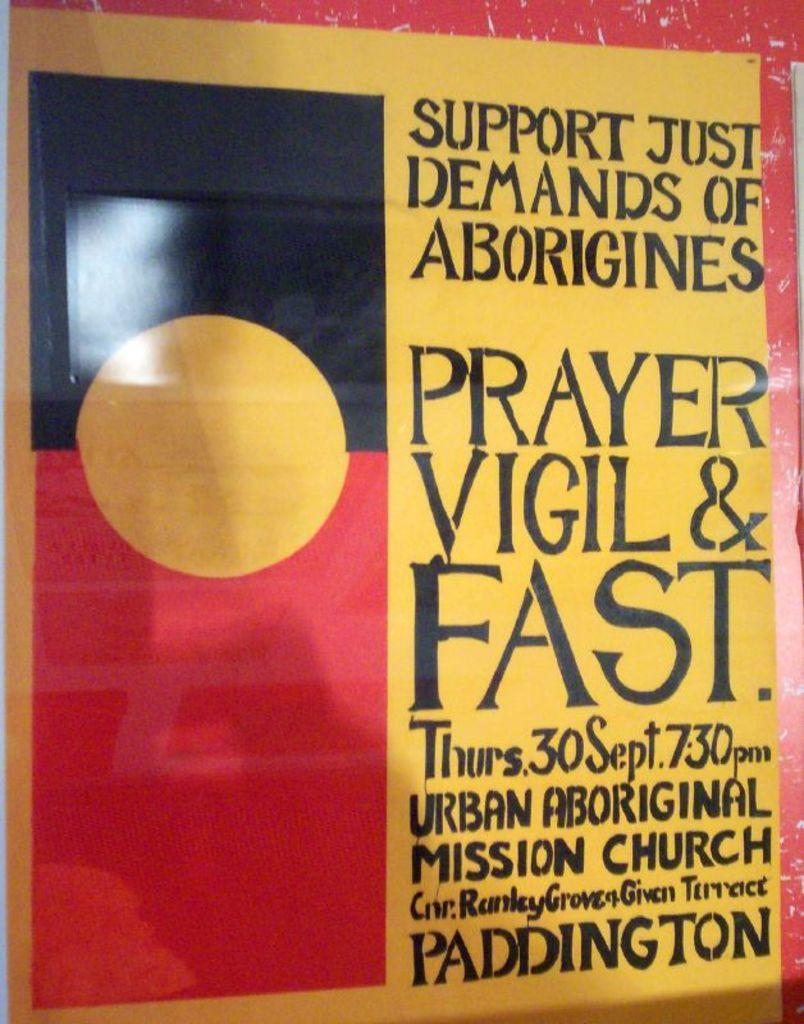<image>
Share a concise interpretation of the image provided. An event is scheduled on Thursday, September 30th at 7:30 pm. 